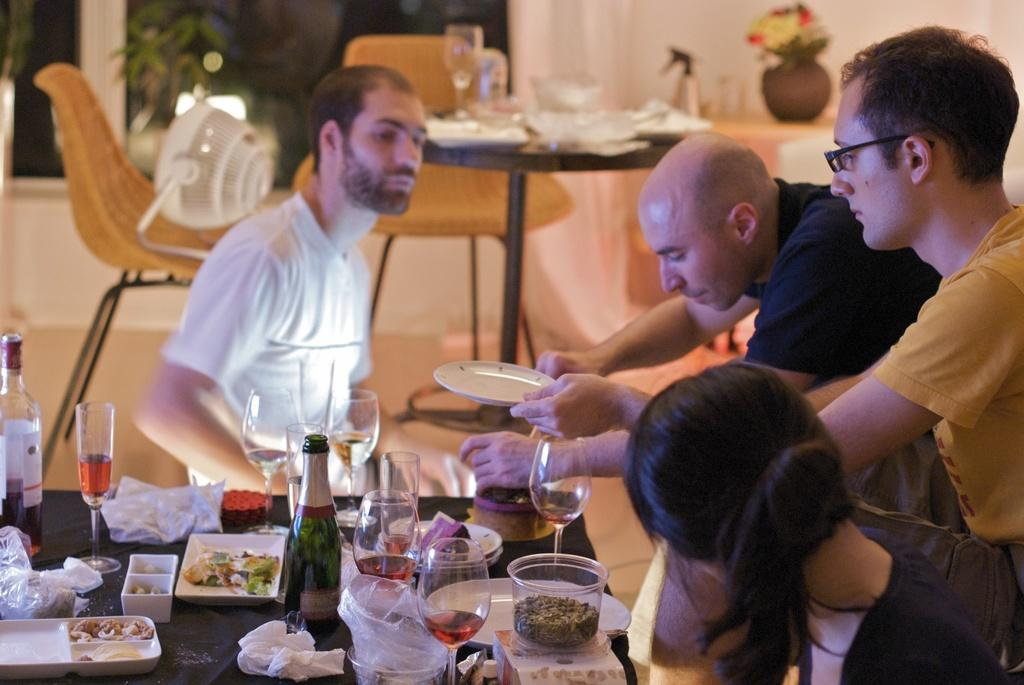Who is present in the image? There are people in the image. What are the people doing in the image? The people are serving themselves from a table. What can be found on the table? There are eatables on the table. Can you describe the man in the image? There is a man in the image, and he is watching the people serve themselves. How many glasses of water are on the table in the image? There is no mention of glasses or water in the image; it only shows people serving themselves from a table with eatables. 